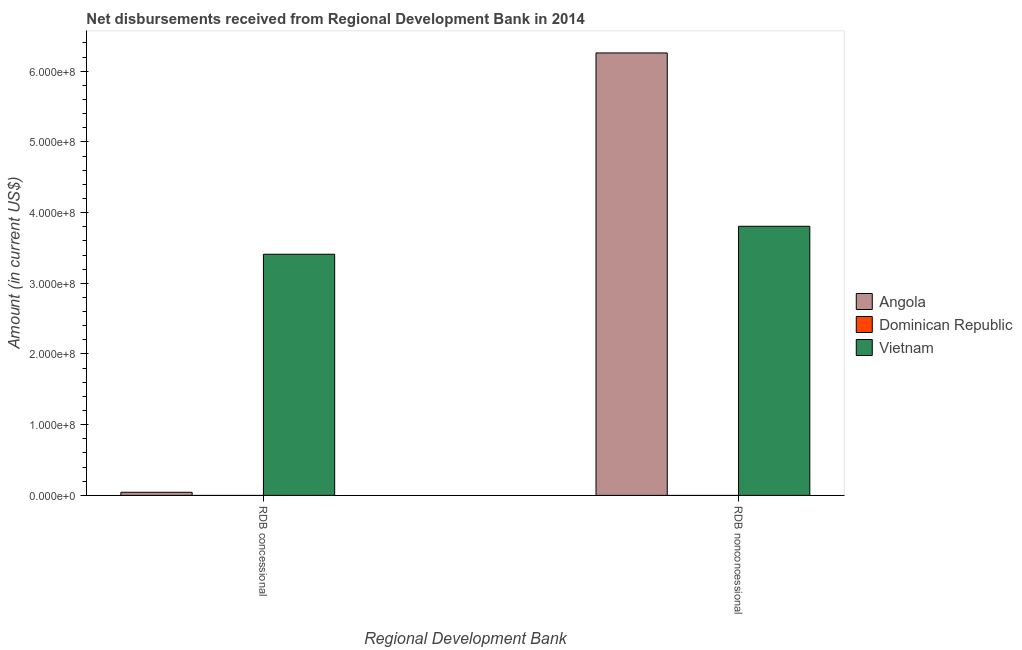Are the number of bars per tick equal to the number of legend labels?
Keep it short and to the point. No. Are the number of bars on each tick of the X-axis equal?
Offer a very short reply. Yes. How many bars are there on the 2nd tick from the right?
Your response must be concise. 2. What is the label of the 1st group of bars from the left?
Your answer should be compact. RDB concessional. What is the net concessional disbursements from rdb in Angola?
Offer a terse response. 4.41e+06. Across all countries, what is the maximum net non concessional disbursements from rdb?
Provide a short and direct response. 6.26e+08. In which country was the net non concessional disbursements from rdb maximum?
Give a very brief answer. Angola. What is the total net non concessional disbursements from rdb in the graph?
Provide a succinct answer. 1.01e+09. What is the difference between the net concessional disbursements from rdb in Angola and that in Vietnam?
Keep it short and to the point. -3.37e+08. What is the difference between the net non concessional disbursements from rdb in Angola and the net concessional disbursements from rdb in Dominican Republic?
Offer a very short reply. 6.26e+08. What is the average net concessional disbursements from rdb per country?
Ensure brevity in your answer.  1.15e+08. What is the difference between the net concessional disbursements from rdb and net non concessional disbursements from rdb in Vietnam?
Offer a very short reply. -3.96e+07. What is the ratio of the net non concessional disbursements from rdb in Vietnam to that in Angola?
Your answer should be compact. 0.61. In how many countries, is the net concessional disbursements from rdb greater than the average net concessional disbursements from rdb taken over all countries?
Give a very brief answer. 1. How many bars are there?
Your answer should be compact. 4. Are all the bars in the graph horizontal?
Provide a succinct answer. No. What is the difference between two consecutive major ticks on the Y-axis?
Give a very brief answer. 1.00e+08. Are the values on the major ticks of Y-axis written in scientific E-notation?
Offer a very short reply. Yes. Does the graph contain any zero values?
Offer a very short reply. Yes. Does the graph contain grids?
Provide a short and direct response. No. How many legend labels are there?
Give a very brief answer. 3. How are the legend labels stacked?
Keep it short and to the point. Vertical. What is the title of the graph?
Offer a very short reply. Net disbursements received from Regional Development Bank in 2014. Does "Channel Islands" appear as one of the legend labels in the graph?
Ensure brevity in your answer.  No. What is the label or title of the X-axis?
Provide a short and direct response. Regional Development Bank. What is the Amount (in current US$) of Angola in RDB concessional?
Keep it short and to the point. 4.41e+06. What is the Amount (in current US$) of Dominican Republic in RDB concessional?
Provide a short and direct response. 0. What is the Amount (in current US$) of Vietnam in RDB concessional?
Offer a terse response. 3.41e+08. What is the Amount (in current US$) of Angola in RDB nonconcessional?
Offer a very short reply. 6.26e+08. What is the Amount (in current US$) in Vietnam in RDB nonconcessional?
Your response must be concise. 3.81e+08. Across all Regional Development Bank, what is the maximum Amount (in current US$) of Angola?
Your response must be concise. 6.26e+08. Across all Regional Development Bank, what is the maximum Amount (in current US$) of Vietnam?
Offer a very short reply. 3.81e+08. Across all Regional Development Bank, what is the minimum Amount (in current US$) of Angola?
Your response must be concise. 4.41e+06. Across all Regional Development Bank, what is the minimum Amount (in current US$) of Vietnam?
Make the answer very short. 3.41e+08. What is the total Amount (in current US$) of Angola in the graph?
Give a very brief answer. 6.30e+08. What is the total Amount (in current US$) of Vietnam in the graph?
Your response must be concise. 7.22e+08. What is the difference between the Amount (in current US$) in Angola in RDB concessional and that in RDB nonconcessional?
Provide a succinct answer. -6.21e+08. What is the difference between the Amount (in current US$) in Vietnam in RDB concessional and that in RDB nonconcessional?
Offer a terse response. -3.96e+07. What is the difference between the Amount (in current US$) of Angola in RDB concessional and the Amount (in current US$) of Vietnam in RDB nonconcessional?
Keep it short and to the point. -3.76e+08. What is the average Amount (in current US$) of Angola per Regional Development Bank?
Your answer should be very brief. 3.15e+08. What is the average Amount (in current US$) in Vietnam per Regional Development Bank?
Give a very brief answer. 3.61e+08. What is the difference between the Amount (in current US$) in Angola and Amount (in current US$) in Vietnam in RDB concessional?
Your answer should be very brief. -3.37e+08. What is the difference between the Amount (in current US$) in Angola and Amount (in current US$) in Vietnam in RDB nonconcessional?
Offer a terse response. 2.45e+08. What is the ratio of the Amount (in current US$) of Angola in RDB concessional to that in RDB nonconcessional?
Make the answer very short. 0.01. What is the ratio of the Amount (in current US$) in Vietnam in RDB concessional to that in RDB nonconcessional?
Provide a succinct answer. 0.9. What is the difference between the highest and the second highest Amount (in current US$) in Angola?
Your response must be concise. 6.21e+08. What is the difference between the highest and the second highest Amount (in current US$) in Vietnam?
Your answer should be very brief. 3.96e+07. What is the difference between the highest and the lowest Amount (in current US$) of Angola?
Offer a very short reply. 6.21e+08. What is the difference between the highest and the lowest Amount (in current US$) of Vietnam?
Provide a short and direct response. 3.96e+07. 